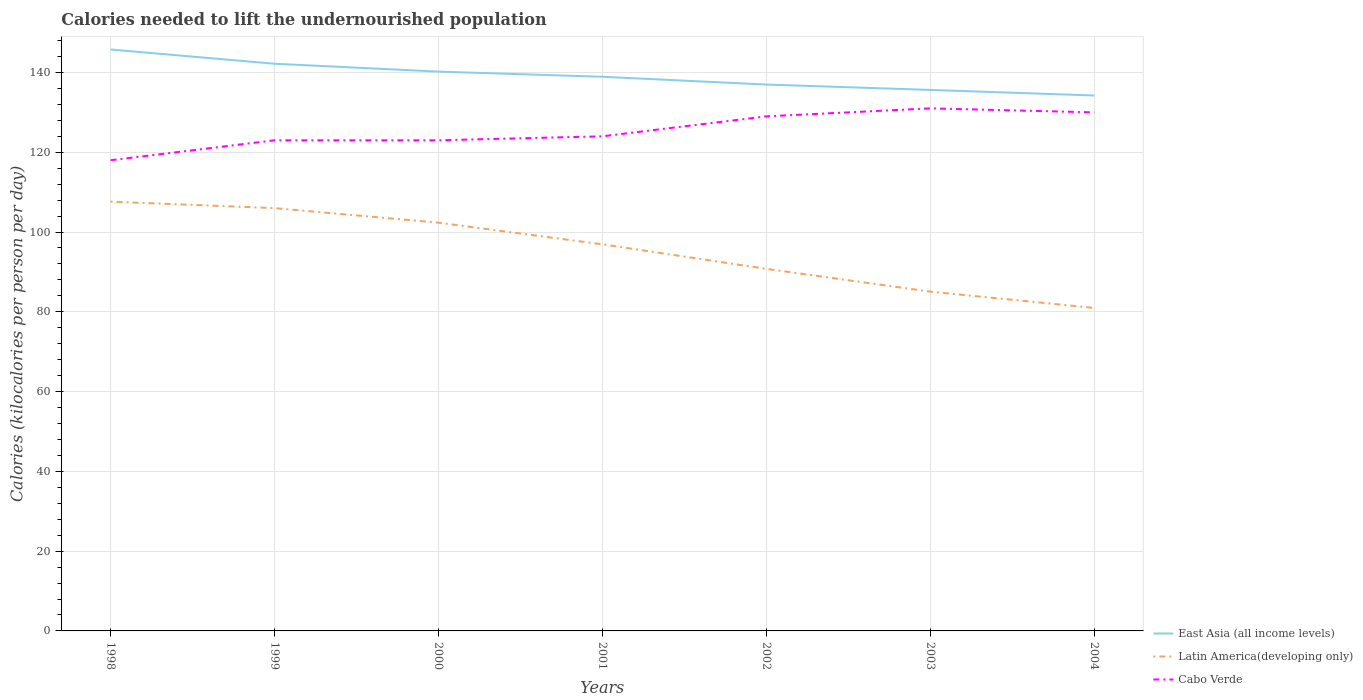How many different coloured lines are there?
Provide a succinct answer. 3. Does the line corresponding to Cabo Verde intersect with the line corresponding to East Asia (all income levels)?
Offer a very short reply. No. Is the number of lines equal to the number of legend labels?
Offer a terse response. Yes. Across all years, what is the maximum total calories needed to lift the undernourished population in Latin America(developing only)?
Your answer should be very brief. 80.97. In which year was the total calories needed to lift the undernourished population in Latin America(developing only) maximum?
Give a very brief answer. 2004. What is the total total calories needed to lift the undernourished population in East Asia (all income levels) in the graph?
Your answer should be very brief. 8.79. What is the difference between the highest and the second highest total calories needed to lift the undernourished population in Cabo Verde?
Make the answer very short. 13. What is the difference between the highest and the lowest total calories needed to lift the undernourished population in Cabo Verde?
Your answer should be very brief. 3. Is the total calories needed to lift the undernourished population in East Asia (all income levels) strictly greater than the total calories needed to lift the undernourished population in Cabo Verde over the years?
Offer a terse response. No. How many lines are there?
Offer a very short reply. 3. Are the values on the major ticks of Y-axis written in scientific E-notation?
Provide a short and direct response. No. Does the graph contain any zero values?
Your response must be concise. No. How many legend labels are there?
Provide a succinct answer. 3. What is the title of the graph?
Offer a very short reply. Calories needed to lift the undernourished population. Does "Pakistan" appear as one of the legend labels in the graph?
Give a very brief answer. No. What is the label or title of the Y-axis?
Offer a terse response. Calories (kilocalories per person per day). What is the Calories (kilocalories per person per day) of East Asia (all income levels) in 1998?
Your answer should be compact. 145.76. What is the Calories (kilocalories per person per day) in Latin America(developing only) in 1998?
Ensure brevity in your answer.  107.62. What is the Calories (kilocalories per person per day) in Cabo Verde in 1998?
Your answer should be compact. 118. What is the Calories (kilocalories per person per day) of East Asia (all income levels) in 1999?
Your response must be concise. 142.19. What is the Calories (kilocalories per person per day) of Latin America(developing only) in 1999?
Your answer should be compact. 105.99. What is the Calories (kilocalories per person per day) of Cabo Verde in 1999?
Offer a very short reply. 123. What is the Calories (kilocalories per person per day) of East Asia (all income levels) in 2000?
Your answer should be compact. 140.22. What is the Calories (kilocalories per person per day) in Latin America(developing only) in 2000?
Make the answer very short. 102.35. What is the Calories (kilocalories per person per day) in Cabo Verde in 2000?
Provide a succinct answer. 123. What is the Calories (kilocalories per person per day) of East Asia (all income levels) in 2001?
Make the answer very short. 138.92. What is the Calories (kilocalories per person per day) of Latin America(developing only) in 2001?
Ensure brevity in your answer.  96.92. What is the Calories (kilocalories per person per day) of Cabo Verde in 2001?
Offer a very short reply. 124. What is the Calories (kilocalories per person per day) in East Asia (all income levels) in 2002?
Provide a short and direct response. 136.97. What is the Calories (kilocalories per person per day) of Latin America(developing only) in 2002?
Provide a succinct answer. 90.77. What is the Calories (kilocalories per person per day) of Cabo Verde in 2002?
Offer a terse response. 129. What is the Calories (kilocalories per person per day) in East Asia (all income levels) in 2003?
Make the answer very short. 135.63. What is the Calories (kilocalories per person per day) in Latin America(developing only) in 2003?
Your answer should be compact. 85.06. What is the Calories (kilocalories per person per day) of Cabo Verde in 2003?
Offer a very short reply. 131. What is the Calories (kilocalories per person per day) of East Asia (all income levels) in 2004?
Your response must be concise. 134.23. What is the Calories (kilocalories per person per day) in Latin America(developing only) in 2004?
Offer a very short reply. 80.97. What is the Calories (kilocalories per person per day) in Cabo Verde in 2004?
Ensure brevity in your answer.  130. Across all years, what is the maximum Calories (kilocalories per person per day) in East Asia (all income levels)?
Offer a terse response. 145.76. Across all years, what is the maximum Calories (kilocalories per person per day) of Latin America(developing only)?
Your answer should be very brief. 107.62. Across all years, what is the maximum Calories (kilocalories per person per day) of Cabo Verde?
Provide a short and direct response. 131. Across all years, what is the minimum Calories (kilocalories per person per day) of East Asia (all income levels)?
Your response must be concise. 134.23. Across all years, what is the minimum Calories (kilocalories per person per day) of Latin America(developing only)?
Ensure brevity in your answer.  80.97. Across all years, what is the minimum Calories (kilocalories per person per day) in Cabo Verde?
Your answer should be compact. 118. What is the total Calories (kilocalories per person per day) of East Asia (all income levels) in the graph?
Your answer should be compact. 973.92. What is the total Calories (kilocalories per person per day) of Latin America(developing only) in the graph?
Provide a succinct answer. 669.67. What is the total Calories (kilocalories per person per day) of Cabo Verde in the graph?
Your answer should be very brief. 878. What is the difference between the Calories (kilocalories per person per day) in East Asia (all income levels) in 1998 and that in 1999?
Provide a short and direct response. 3.57. What is the difference between the Calories (kilocalories per person per day) of Latin America(developing only) in 1998 and that in 1999?
Provide a short and direct response. 1.63. What is the difference between the Calories (kilocalories per person per day) of Cabo Verde in 1998 and that in 1999?
Ensure brevity in your answer.  -5. What is the difference between the Calories (kilocalories per person per day) of East Asia (all income levels) in 1998 and that in 2000?
Your answer should be compact. 5.54. What is the difference between the Calories (kilocalories per person per day) of Latin America(developing only) in 1998 and that in 2000?
Ensure brevity in your answer.  5.28. What is the difference between the Calories (kilocalories per person per day) in East Asia (all income levels) in 1998 and that in 2001?
Ensure brevity in your answer.  6.83. What is the difference between the Calories (kilocalories per person per day) in Latin America(developing only) in 1998 and that in 2001?
Provide a succinct answer. 10.7. What is the difference between the Calories (kilocalories per person per day) of East Asia (all income levels) in 1998 and that in 2002?
Your answer should be compact. 8.79. What is the difference between the Calories (kilocalories per person per day) in Latin America(developing only) in 1998 and that in 2002?
Offer a very short reply. 16.85. What is the difference between the Calories (kilocalories per person per day) in East Asia (all income levels) in 1998 and that in 2003?
Offer a terse response. 10.13. What is the difference between the Calories (kilocalories per person per day) of Latin America(developing only) in 1998 and that in 2003?
Offer a very short reply. 22.56. What is the difference between the Calories (kilocalories per person per day) in East Asia (all income levels) in 1998 and that in 2004?
Your answer should be very brief. 11.53. What is the difference between the Calories (kilocalories per person per day) in Latin America(developing only) in 1998 and that in 2004?
Provide a short and direct response. 26.65. What is the difference between the Calories (kilocalories per person per day) in Cabo Verde in 1998 and that in 2004?
Provide a succinct answer. -12. What is the difference between the Calories (kilocalories per person per day) in East Asia (all income levels) in 1999 and that in 2000?
Offer a terse response. 1.97. What is the difference between the Calories (kilocalories per person per day) of Latin America(developing only) in 1999 and that in 2000?
Your answer should be very brief. 3.65. What is the difference between the Calories (kilocalories per person per day) in East Asia (all income levels) in 1999 and that in 2001?
Give a very brief answer. 3.27. What is the difference between the Calories (kilocalories per person per day) of Latin America(developing only) in 1999 and that in 2001?
Offer a terse response. 9.07. What is the difference between the Calories (kilocalories per person per day) in East Asia (all income levels) in 1999 and that in 2002?
Your response must be concise. 5.22. What is the difference between the Calories (kilocalories per person per day) of Latin America(developing only) in 1999 and that in 2002?
Provide a short and direct response. 15.22. What is the difference between the Calories (kilocalories per person per day) in Cabo Verde in 1999 and that in 2002?
Your answer should be compact. -6. What is the difference between the Calories (kilocalories per person per day) of East Asia (all income levels) in 1999 and that in 2003?
Your response must be concise. 6.56. What is the difference between the Calories (kilocalories per person per day) of Latin America(developing only) in 1999 and that in 2003?
Keep it short and to the point. 20.93. What is the difference between the Calories (kilocalories per person per day) of Cabo Verde in 1999 and that in 2003?
Give a very brief answer. -8. What is the difference between the Calories (kilocalories per person per day) in East Asia (all income levels) in 1999 and that in 2004?
Provide a short and direct response. 7.96. What is the difference between the Calories (kilocalories per person per day) in Latin America(developing only) in 1999 and that in 2004?
Your answer should be compact. 25.02. What is the difference between the Calories (kilocalories per person per day) in East Asia (all income levels) in 2000 and that in 2001?
Offer a very short reply. 1.29. What is the difference between the Calories (kilocalories per person per day) in Latin America(developing only) in 2000 and that in 2001?
Provide a succinct answer. 5.43. What is the difference between the Calories (kilocalories per person per day) in East Asia (all income levels) in 2000 and that in 2002?
Your answer should be very brief. 3.25. What is the difference between the Calories (kilocalories per person per day) in Latin America(developing only) in 2000 and that in 2002?
Offer a terse response. 11.58. What is the difference between the Calories (kilocalories per person per day) in East Asia (all income levels) in 2000 and that in 2003?
Offer a terse response. 4.59. What is the difference between the Calories (kilocalories per person per day) in Latin America(developing only) in 2000 and that in 2003?
Keep it short and to the point. 17.29. What is the difference between the Calories (kilocalories per person per day) of East Asia (all income levels) in 2000 and that in 2004?
Your answer should be compact. 5.99. What is the difference between the Calories (kilocalories per person per day) of Latin America(developing only) in 2000 and that in 2004?
Offer a very short reply. 21.38. What is the difference between the Calories (kilocalories per person per day) of East Asia (all income levels) in 2001 and that in 2002?
Provide a succinct answer. 1.95. What is the difference between the Calories (kilocalories per person per day) in Latin America(developing only) in 2001 and that in 2002?
Your answer should be very brief. 6.15. What is the difference between the Calories (kilocalories per person per day) of Cabo Verde in 2001 and that in 2002?
Your answer should be very brief. -5. What is the difference between the Calories (kilocalories per person per day) in East Asia (all income levels) in 2001 and that in 2003?
Offer a very short reply. 3.3. What is the difference between the Calories (kilocalories per person per day) of Latin America(developing only) in 2001 and that in 2003?
Offer a very short reply. 11.86. What is the difference between the Calories (kilocalories per person per day) of East Asia (all income levels) in 2001 and that in 2004?
Your answer should be very brief. 4.7. What is the difference between the Calories (kilocalories per person per day) in Latin America(developing only) in 2001 and that in 2004?
Provide a succinct answer. 15.95. What is the difference between the Calories (kilocalories per person per day) of East Asia (all income levels) in 2002 and that in 2003?
Your response must be concise. 1.34. What is the difference between the Calories (kilocalories per person per day) in Latin America(developing only) in 2002 and that in 2003?
Provide a succinct answer. 5.71. What is the difference between the Calories (kilocalories per person per day) in East Asia (all income levels) in 2002 and that in 2004?
Offer a terse response. 2.74. What is the difference between the Calories (kilocalories per person per day) of Latin America(developing only) in 2002 and that in 2004?
Your answer should be very brief. 9.8. What is the difference between the Calories (kilocalories per person per day) of Cabo Verde in 2002 and that in 2004?
Provide a succinct answer. -1. What is the difference between the Calories (kilocalories per person per day) in East Asia (all income levels) in 2003 and that in 2004?
Make the answer very short. 1.4. What is the difference between the Calories (kilocalories per person per day) of Latin America(developing only) in 2003 and that in 2004?
Keep it short and to the point. 4.09. What is the difference between the Calories (kilocalories per person per day) in East Asia (all income levels) in 1998 and the Calories (kilocalories per person per day) in Latin America(developing only) in 1999?
Your answer should be very brief. 39.77. What is the difference between the Calories (kilocalories per person per day) of East Asia (all income levels) in 1998 and the Calories (kilocalories per person per day) of Cabo Verde in 1999?
Offer a very short reply. 22.76. What is the difference between the Calories (kilocalories per person per day) of Latin America(developing only) in 1998 and the Calories (kilocalories per person per day) of Cabo Verde in 1999?
Provide a short and direct response. -15.38. What is the difference between the Calories (kilocalories per person per day) of East Asia (all income levels) in 1998 and the Calories (kilocalories per person per day) of Latin America(developing only) in 2000?
Provide a succinct answer. 43.41. What is the difference between the Calories (kilocalories per person per day) in East Asia (all income levels) in 1998 and the Calories (kilocalories per person per day) in Cabo Verde in 2000?
Offer a very short reply. 22.76. What is the difference between the Calories (kilocalories per person per day) of Latin America(developing only) in 1998 and the Calories (kilocalories per person per day) of Cabo Verde in 2000?
Keep it short and to the point. -15.38. What is the difference between the Calories (kilocalories per person per day) of East Asia (all income levels) in 1998 and the Calories (kilocalories per person per day) of Latin America(developing only) in 2001?
Provide a short and direct response. 48.84. What is the difference between the Calories (kilocalories per person per day) in East Asia (all income levels) in 1998 and the Calories (kilocalories per person per day) in Cabo Verde in 2001?
Offer a very short reply. 21.76. What is the difference between the Calories (kilocalories per person per day) of Latin America(developing only) in 1998 and the Calories (kilocalories per person per day) of Cabo Verde in 2001?
Ensure brevity in your answer.  -16.38. What is the difference between the Calories (kilocalories per person per day) of East Asia (all income levels) in 1998 and the Calories (kilocalories per person per day) of Latin America(developing only) in 2002?
Provide a short and direct response. 54.99. What is the difference between the Calories (kilocalories per person per day) of East Asia (all income levels) in 1998 and the Calories (kilocalories per person per day) of Cabo Verde in 2002?
Offer a terse response. 16.76. What is the difference between the Calories (kilocalories per person per day) in Latin America(developing only) in 1998 and the Calories (kilocalories per person per day) in Cabo Verde in 2002?
Make the answer very short. -21.38. What is the difference between the Calories (kilocalories per person per day) of East Asia (all income levels) in 1998 and the Calories (kilocalories per person per day) of Latin America(developing only) in 2003?
Your answer should be compact. 60.7. What is the difference between the Calories (kilocalories per person per day) of East Asia (all income levels) in 1998 and the Calories (kilocalories per person per day) of Cabo Verde in 2003?
Ensure brevity in your answer.  14.76. What is the difference between the Calories (kilocalories per person per day) in Latin America(developing only) in 1998 and the Calories (kilocalories per person per day) in Cabo Verde in 2003?
Your response must be concise. -23.38. What is the difference between the Calories (kilocalories per person per day) in East Asia (all income levels) in 1998 and the Calories (kilocalories per person per day) in Latin America(developing only) in 2004?
Ensure brevity in your answer.  64.79. What is the difference between the Calories (kilocalories per person per day) in East Asia (all income levels) in 1998 and the Calories (kilocalories per person per day) in Cabo Verde in 2004?
Your answer should be compact. 15.76. What is the difference between the Calories (kilocalories per person per day) of Latin America(developing only) in 1998 and the Calories (kilocalories per person per day) of Cabo Verde in 2004?
Ensure brevity in your answer.  -22.38. What is the difference between the Calories (kilocalories per person per day) of East Asia (all income levels) in 1999 and the Calories (kilocalories per person per day) of Latin America(developing only) in 2000?
Provide a succinct answer. 39.84. What is the difference between the Calories (kilocalories per person per day) in East Asia (all income levels) in 1999 and the Calories (kilocalories per person per day) in Cabo Verde in 2000?
Your response must be concise. 19.19. What is the difference between the Calories (kilocalories per person per day) in Latin America(developing only) in 1999 and the Calories (kilocalories per person per day) in Cabo Verde in 2000?
Keep it short and to the point. -17.01. What is the difference between the Calories (kilocalories per person per day) of East Asia (all income levels) in 1999 and the Calories (kilocalories per person per day) of Latin America(developing only) in 2001?
Provide a succinct answer. 45.27. What is the difference between the Calories (kilocalories per person per day) in East Asia (all income levels) in 1999 and the Calories (kilocalories per person per day) in Cabo Verde in 2001?
Ensure brevity in your answer.  18.19. What is the difference between the Calories (kilocalories per person per day) of Latin America(developing only) in 1999 and the Calories (kilocalories per person per day) of Cabo Verde in 2001?
Give a very brief answer. -18.01. What is the difference between the Calories (kilocalories per person per day) in East Asia (all income levels) in 1999 and the Calories (kilocalories per person per day) in Latin America(developing only) in 2002?
Your response must be concise. 51.42. What is the difference between the Calories (kilocalories per person per day) in East Asia (all income levels) in 1999 and the Calories (kilocalories per person per day) in Cabo Verde in 2002?
Make the answer very short. 13.19. What is the difference between the Calories (kilocalories per person per day) of Latin America(developing only) in 1999 and the Calories (kilocalories per person per day) of Cabo Verde in 2002?
Offer a terse response. -23.01. What is the difference between the Calories (kilocalories per person per day) in East Asia (all income levels) in 1999 and the Calories (kilocalories per person per day) in Latin America(developing only) in 2003?
Ensure brevity in your answer.  57.13. What is the difference between the Calories (kilocalories per person per day) of East Asia (all income levels) in 1999 and the Calories (kilocalories per person per day) of Cabo Verde in 2003?
Your answer should be compact. 11.19. What is the difference between the Calories (kilocalories per person per day) of Latin America(developing only) in 1999 and the Calories (kilocalories per person per day) of Cabo Verde in 2003?
Make the answer very short. -25.01. What is the difference between the Calories (kilocalories per person per day) in East Asia (all income levels) in 1999 and the Calories (kilocalories per person per day) in Latin America(developing only) in 2004?
Provide a succinct answer. 61.22. What is the difference between the Calories (kilocalories per person per day) of East Asia (all income levels) in 1999 and the Calories (kilocalories per person per day) of Cabo Verde in 2004?
Make the answer very short. 12.19. What is the difference between the Calories (kilocalories per person per day) in Latin America(developing only) in 1999 and the Calories (kilocalories per person per day) in Cabo Verde in 2004?
Ensure brevity in your answer.  -24.01. What is the difference between the Calories (kilocalories per person per day) of East Asia (all income levels) in 2000 and the Calories (kilocalories per person per day) of Latin America(developing only) in 2001?
Provide a succinct answer. 43.3. What is the difference between the Calories (kilocalories per person per day) in East Asia (all income levels) in 2000 and the Calories (kilocalories per person per day) in Cabo Verde in 2001?
Provide a succinct answer. 16.22. What is the difference between the Calories (kilocalories per person per day) in Latin America(developing only) in 2000 and the Calories (kilocalories per person per day) in Cabo Verde in 2001?
Your answer should be very brief. -21.65. What is the difference between the Calories (kilocalories per person per day) of East Asia (all income levels) in 2000 and the Calories (kilocalories per person per day) of Latin America(developing only) in 2002?
Keep it short and to the point. 49.45. What is the difference between the Calories (kilocalories per person per day) in East Asia (all income levels) in 2000 and the Calories (kilocalories per person per day) in Cabo Verde in 2002?
Your answer should be compact. 11.22. What is the difference between the Calories (kilocalories per person per day) of Latin America(developing only) in 2000 and the Calories (kilocalories per person per day) of Cabo Verde in 2002?
Your answer should be compact. -26.65. What is the difference between the Calories (kilocalories per person per day) in East Asia (all income levels) in 2000 and the Calories (kilocalories per person per day) in Latin America(developing only) in 2003?
Your response must be concise. 55.16. What is the difference between the Calories (kilocalories per person per day) in East Asia (all income levels) in 2000 and the Calories (kilocalories per person per day) in Cabo Verde in 2003?
Your answer should be compact. 9.22. What is the difference between the Calories (kilocalories per person per day) in Latin America(developing only) in 2000 and the Calories (kilocalories per person per day) in Cabo Verde in 2003?
Your response must be concise. -28.65. What is the difference between the Calories (kilocalories per person per day) of East Asia (all income levels) in 2000 and the Calories (kilocalories per person per day) of Latin America(developing only) in 2004?
Give a very brief answer. 59.25. What is the difference between the Calories (kilocalories per person per day) of East Asia (all income levels) in 2000 and the Calories (kilocalories per person per day) of Cabo Verde in 2004?
Provide a short and direct response. 10.22. What is the difference between the Calories (kilocalories per person per day) in Latin America(developing only) in 2000 and the Calories (kilocalories per person per day) in Cabo Verde in 2004?
Offer a very short reply. -27.65. What is the difference between the Calories (kilocalories per person per day) of East Asia (all income levels) in 2001 and the Calories (kilocalories per person per day) of Latin America(developing only) in 2002?
Your response must be concise. 48.16. What is the difference between the Calories (kilocalories per person per day) in East Asia (all income levels) in 2001 and the Calories (kilocalories per person per day) in Cabo Verde in 2002?
Keep it short and to the point. 9.92. What is the difference between the Calories (kilocalories per person per day) in Latin America(developing only) in 2001 and the Calories (kilocalories per person per day) in Cabo Verde in 2002?
Provide a succinct answer. -32.08. What is the difference between the Calories (kilocalories per person per day) in East Asia (all income levels) in 2001 and the Calories (kilocalories per person per day) in Latin America(developing only) in 2003?
Your answer should be very brief. 53.87. What is the difference between the Calories (kilocalories per person per day) in East Asia (all income levels) in 2001 and the Calories (kilocalories per person per day) in Cabo Verde in 2003?
Your answer should be compact. 7.92. What is the difference between the Calories (kilocalories per person per day) of Latin America(developing only) in 2001 and the Calories (kilocalories per person per day) of Cabo Verde in 2003?
Provide a short and direct response. -34.08. What is the difference between the Calories (kilocalories per person per day) of East Asia (all income levels) in 2001 and the Calories (kilocalories per person per day) of Latin America(developing only) in 2004?
Give a very brief answer. 57.96. What is the difference between the Calories (kilocalories per person per day) in East Asia (all income levels) in 2001 and the Calories (kilocalories per person per day) in Cabo Verde in 2004?
Give a very brief answer. 8.92. What is the difference between the Calories (kilocalories per person per day) in Latin America(developing only) in 2001 and the Calories (kilocalories per person per day) in Cabo Verde in 2004?
Keep it short and to the point. -33.08. What is the difference between the Calories (kilocalories per person per day) of East Asia (all income levels) in 2002 and the Calories (kilocalories per person per day) of Latin America(developing only) in 2003?
Keep it short and to the point. 51.91. What is the difference between the Calories (kilocalories per person per day) of East Asia (all income levels) in 2002 and the Calories (kilocalories per person per day) of Cabo Verde in 2003?
Ensure brevity in your answer.  5.97. What is the difference between the Calories (kilocalories per person per day) of Latin America(developing only) in 2002 and the Calories (kilocalories per person per day) of Cabo Verde in 2003?
Give a very brief answer. -40.23. What is the difference between the Calories (kilocalories per person per day) in East Asia (all income levels) in 2002 and the Calories (kilocalories per person per day) in Latin America(developing only) in 2004?
Your answer should be compact. 56. What is the difference between the Calories (kilocalories per person per day) in East Asia (all income levels) in 2002 and the Calories (kilocalories per person per day) in Cabo Verde in 2004?
Ensure brevity in your answer.  6.97. What is the difference between the Calories (kilocalories per person per day) in Latin America(developing only) in 2002 and the Calories (kilocalories per person per day) in Cabo Verde in 2004?
Provide a succinct answer. -39.23. What is the difference between the Calories (kilocalories per person per day) in East Asia (all income levels) in 2003 and the Calories (kilocalories per person per day) in Latin America(developing only) in 2004?
Provide a succinct answer. 54.66. What is the difference between the Calories (kilocalories per person per day) in East Asia (all income levels) in 2003 and the Calories (kilocalories per person per day) in Cabo Verde in 2004?
Provide a short and direct response. 5.63. What is the difference between the Calories (kilocalories per person per day) of Latin America(developing only) in 2003 and the Calories (kilocalories per person per day) of Cabo Verde in 2004?
Offer a terse response. -44.94. What is the average Calories (kilocalories per person per day) in East Asia (all income levels) per year?
Give a very brief answer. 139.13. What is the average Calories (kilocalories per person per day) of Latin America(developing only) per year?
Make the answer very short. 95.67. What is the average Calories (kilocalories per person per day) of Cabo Verde per year?
Your answer should be very brief. 125.43. In the year 1998, what is the difference between the Calories (kilocalories per person per day) of East Asia (all income levels) and Calories (kilocalories per person per day) of Latin America(developing only)?
Your response must be concise. 38.14. In the year 1998, what is the difference between the Calories (kilocalories per person per day) of East Asia (all income levels) and Calories (kilocalories per person per day) of Cabo Verde?
Provide a succinct answer. 27.76. In the year 1998, what is the difference between the Calories (kilocalories per person per day) of Latin America(developing only) and Calories (kilocalories per person per day) of Cabo Verde?
Offer a very short reply. -10.38. In the year 1999, what is the difference between the Calories (kilocalories per person per day) in East Asia (all income levels) and Calories (kilocalories per person per day) in Latin America(developing only)?
Offer a terse response. 36.2. In the year 1999, what is the difference between the Calories (kilocalories per person per day) in East Asia (all income levels) and Calories (kilocalories per person per day) in Cabo Verde?
Ensure brevity in your answer.  19.19. In the year 1999, what is the difference between the Calories (kilocalories per person per day) in Latin America(developing only) and Calories (kilocalories per person per day) in Cabo Verde?
Your answer should be very brief. -17.01. In the year 2000, what is the difference between the Calories (kilocalories per person per day) in East Asia (all income levels) and Calories (kilocalories per person per day) in Latin America(developing only)?
Give a very brief answer. 37.87. In the year 2000, what is the difference between the Calories (kilocalories per person per day) in East Asia (all income levels) and Calories (kilocalories per person per day) in Cabo Verde?
Your response must be concise. 17.22. In the year 2000, what is the difference between the Calories (kilocalories per person per day) of Latin America(developing only) and Calories (kilocalories per person per day) of Cabo Verde?
Your response must be concise. -20.65. In the year 2001, what is the difference between the Calories (kilocalories per person per day) of East Asia (all income levels) and Calories (kilocalories per person per day) of Latin America(developing only)?
Ensure brevity in your answer.  42.01. In the year 2001, what is the difference between the Calories (kilocalories per person per day) of East Asia (all income levels) and Calories (kilocalories per person per day) of Cabo Verde?
Your answer should be compact. 14.92. In the year 2001, what is the difference between the Calories (kilocalories per person per day) in Latin America(developing only) and Calories (kilocalories per person per day) in Cabo Verde?
Make the answer very short. -27.08. In the year 2002, what is the difference between the Calories (kilocalories per person per day) in East Asia (all income levels) and Calories (kilocalories per person per day) in Latin America(developing only)?
Your answer should be compact. 46.2. In the year 2002, what is the difference between the Calories (kilocalories per person per day) in East Asia (all income levels) and Calories (kilocalories per person per day) in Cabo Verde?
Your answer should be compact. 7.97. In the year 2002, what is the difference between the Calories (kilocalories per person per day) in Latin America(developing only) and Calories (kilocalories per person per day) in Cabo Verde?
Your answer should be very brief. -38.23. In the year 2003, what is the difference between the Calories (kilocalories per person per day) of East Asia (all income levels) and Calories (kilocalories per person per day) of Latin America(developing only)?
Keep it short and to the point. 50.57. In the year 2003, what is the difference between the Calories (kilocalories per person per day) of East Asia (all income levels) and Calories (kilocalories per person per day) of Cabo Verde?
Offer a very short reply. 4.63. In the year 2003, what is the difference between the Calories (kilocalories per person per day) of Latin America(developing only) and Calories (kilocalories per person per day) of Cabo Verde?
Keep it short and to the point. -45.94. In the year 2004, what is the difference between the Calories (kilocalories per person per day) of East Asia (all income levels) and Calories (kilocalories per person per day) of Latin America(developing only)?
Ensure brevity in your answer.  53.26. In the year 2004, what is the difference between the Calories (kilocalories per person per day) in East Asia (all income levels) and Calories (kilocalories per person per day) in Cabo Verde?
Your answer should be very brief. 4.23. In the year 2004, what is the difference between the Calories (kilocalories per person per day) of Latin America(developing only) and Calories (kilocalories per person per day) of Cabo Verde?
Your answer should be compact. -49.03. What is the ratio of the Calories (kilocalories per person per day) of East Asia (all income levels) in 1998 to that in 1999?
Your answer should be very brief. 1.03. What is the ratio of the Calories (kilocalories per person per day) in Latin America(developing only) in 1998 to that in 1999?
Your answer should be compact. 1.02. What is the ratio of the Calories (kilocalories per person per day) of Cabo Verde in 1998 to that in 1999?
Offer a very short reply. 0.96. What is the ratio of the Calories (kilocalories per person per day) of East Asia (all income levels) in 1998 to that in 2000?
Your answer should be very brief. 1.04. What is the ratio of the Calories (kilocalories per person per day) of Latin America(developing only) in 1998 to that in 2000?
Your answer should be compact. 1.05. What is the ratio of the Calories (kilocalories per person per day) of Cabo Verde in 1998 to that in 2000?
Ensure brevity in your answer.  0.96. What is the ratio of the Calories (kilocalories per person per day) in East Asia (all income levels) in 1998 to that in 2001?
Offer a very short reply. 1.05. What is the ratio of the Calories (kilocalories per person per day) of Latin America(developing only) in 1998 to that in 2001?
Your answer should be very brief. 1.11. What is the ratio of the Calories (kilocalories per person per day) of Cabo Verde in 1998 to that in 2001?
Provide a short and direct response. 0.95. What is the ratio of the Calories (kilocalories per person per day) in East Asia (all income levels) in 1998 to that in 2002?
Give a very brief answer. 1.06. What is the ratio of the Calories (kilocalories per person per day) of Latin America(developing only) in 1998 to that in 2002?
Provide a succinct answer. 1.19. What is the ratio of the Calories (kilocalories per person per day) in Cabo Verde in 1998 to that in 2002?
Offer a very short reply. 0.91. What is the ratio of the Calories (kilocalories per person per day) of East Asia (all income levels) in 1998 to that in 2003?
Keep it short and to the point. 1.07. What is the ratio of the Calories (kilocalories per person per day) of Latin America(developing only) in 1998 to that in 2003?
Give a very brief answer. 1.27. What is the ratio of the Calories (kilocalories per person per day) of Cabo Verde in 1998 to that in 2003?
Provide a succinct answer. 0.9. What is the ratio of the Calories (kilocalories per person per day) of East Asia (all income levels) in 1998 to that in 2004?
Provide a succinct answer. 1.09. What is the ratio of the Calories (kilocalories per person per day) of Latin America(developing only) in 1998 to that in 2004?
Provide a short and direct response. 1.33. What is the ratio of the Calories (kilocalories per person per day) of Cabo Verde in 1998 to that in 2004?
Your response must be concise. 0.91. What is the ratio of the Calories (kilocalories per person per day) in East Asia (all income levels) in 1999 to that in 2000?
Your response must be concise. 1.01. What is the ratio of the Calories (kilocalories per person per day) of Latin America(developing only) in 1999 to that in 2000?
Your answer should be very brief. 1.04. What is the ratio of the Calories (kilocalories per person per day) in East Asia (all income levels) in 1999 to that in 2001?
Offer a terse response. 1.02. What is the ratio of the Calories (kilocalories per person per day) of Latin America(developing only) in 1999 to that in 2001?
Provide a short and direct response. 1.09. What is the ratio of the Calories (kilocalories per person per day) in Cabo Verde in 1999 to that in 2001?
Your answer should be very brief. 0.99. What is the ratio of the Calories (kilocalories per person per day) of East Asia (all income levels) in 1999 to that in 2002?
Offer a very short reply. 1.04. What is the ratio of the Calories (kilocalories per person per day) in Latin America(developing only) in 1999 to that in 2002?
Provide a short and direct response. 1.17. What is the ratio of the Calories (kilocalories per person per day) in Cabo Verde in 1999 to that in 2002?
Your answer should be compact. 0.95. What is the ratio of the Calories (kilocalories per person per day) of East Asia (all income levels) in 1999 to that in 2003?
Make the answer very short. 1.05. What is the ratio of the Calories (kilocalories per person per day) of Latin America(developing only) in 1999 to that in 2003?
Make the answer very short. 1.25. What is the ratio of the Calories (kilocalories per person per day) of Cabo Verde in 1999 to that in 2003?
Make the answer very short. 0.94. What is the ratio of the Calories (kilocalories per person per day) of East Asia (all income levels) in 1999 to that in 2004?
Your response must be concise. 1.06. What is the ratio of the Calories (kilocalories per person per day) in Latin America(developing only) in 1999 to that in 2004?
Make the answer very short. 1.31. What is the ratio of the Calories (kilocalories per person per day) in Cabo Verde in 1999 to that in 2004?
Your answer should be very brief. 0.95. What is the ratio of the Calories (kilocalories per person per day) in East Asia (all income levels) in 2000 to that in 2001?
Your answer should be compact. 1.01. What is the ratio of the Calories (kilocalories per person per day) of Latin America(developing only) in 2000 to that in 2001?
Your answer should be compact. 1.06. What is the ratio of the Calories (kilocalories per person per day) of East Asia (all income levels) in 2000 to that in 2002?
Your answer should be very brief. 1.02. What is the ratio of the Calories (kilocalories per person per day) of Latin America(developing only) in 2000 to that in 2002?
Offer a very short reply. 1.13. What is the ratio of the Calories (kilocalories per person per day) of Cabo Verde in 2000 to that in 2002?
Your answer should be compact. 0.95. What is the ratio of the Calories (kilocalories per person per day) of East Asia (all income levels) in 2000 to that in 2003?
Give a very brief answer. 1.03. What is the ratio of the Calories (kilocalories per person per day) in Latin America(developing only) in 2000 to that in 2003?
Give a very brief answer. 1.2. What is the ratio of the Calories (kilocalories per person per day) in Cabo Verde in 2000 to that in 2003?
Your answer should be compact. 0.94. What is the ratio of the Calories (kilocalories per person per day) in East Asia (all income levels) in 2000 to that in 2004?
Make the answer very short. 1.04. What is the ratio of the Calories (kilocalories per person per day) of Latin America(developing only) in 2000 to that in 2004?
Provide a succinct answer. 1.26. What is the ratio of the Calories (kilocalories per person per day) in Cabo Verde in 2000 to that in 2004?
Make the answer very short. 0.95. What is the ratio of the Calories (kilocalories per person per day) of East Asia (all income levels) in 2001 to that in 2002?
Give a very brief answer. 1.01. What is the ratio of the Calories (kilocalories per person per day) of Latin America(developing only) in 2001 to that in 2002?
Make the answer very short. 1.07. What is the ratio of the Calories (kilocalories per person per day) of Cabo Verde in 2001 to that in 2002?
Keep it short and to the point. 0.96. What is the ratio of the Calories (kilocalories per person per day) of East Asia (all income levels) in 2001 to that in 2003?
Offer a very short reply. 1.02. What is the ratio of the Calories (kilocalories per person per day) of Latin America(developing only) in 2001 to that in 2003?
Your answer should be compact. 1.14. What is the ratio of the Calories (kilocalories per person per day) in Cabo Verde in 2001 to that in 2003?
Provide a short and direct response. 0.95. What is the ratio of the Calories (kilocalories per person per day) of East Asia (all income levels) in 2001 to that in 2004?
Provide a short and direct response. 1.03. What is the ratio of the Calories (kilocalories per person per day) in Latin America(developing only) in 2001 to that in 2004?
Your response must be concise. 1.2. What is the ratio of the Calories (kilocalories per person per day) of Cabo Verde in 2001 to that in 2004?
Give a very brief answer. 0.95. What is the ratio of the Calories (kilocalories per person per day) in East Asia (all income levels) in 2002 to that in 2003?
Give a very brief answer. 1.01. What is the ratio of the Calories (kilocalories per person per day) in Latin America(developing only) in 2002 to that in 2003?
Keep it short and to the point. 1.07. What is the ratio of the Calories (kilocalories per person per day) in Cabo Verde in 2002 to that in 2003?
Provide a short and direct response. 0.98. What is the ratio of the Calories (kilocalories per person per day) of East Asia (all income levels) in 2002 to that in 2004?
Provide a short and direct response. 1.02. What is the ratio of the Calories (kilocalories per person per day) in Latin America(developing only) in 2002 to that in 2004?
Your answer should be very brief. 1.12. What is the ratio of the Calories (kilocalories per person per day) of East Asia (all income levels) in 2003 to that in 2004?
Offer a very short reply. 1.01. What is the ratio of the Calories (kilocalories per person per day) in Latin America(developing only) in 2003 to that in 2004?
Give a very brief answer. 1.05. What is the ratio of the Calories (kilocalories per person per day) of Cabo Verde in 2003 to that in 2004?
Your answer should be compact. 1.01. What is the difference between the highest and the second highest Calories (kilocalories per person per day) of East Asia (all income levels)?
Give a very brief answer. 3.57. What is the difference between the highest and the second highest Calories (kilocalories per person per day) of Latin America(developing only)?
Give a very brief answer. 1.63. What is the difference between the highest and the lowest Calories (kilocalories per person per day) of East Asia (all income levels)?
Your response must be concise. 11.53. What is the difference between the highest and the lowest Calories (kilocalories per person per day) in Latin America(developing only)?
Keep it short and to the point. 26.65. What is the difference between the highest and the lowest Calories (kilocalories per person per day) in Cabo Verde?
Ensure brevity in your answer.  13. 